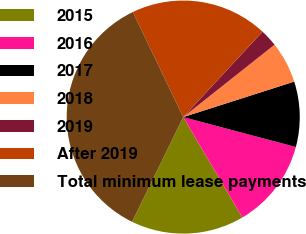<chart> <loc_0><loc_0><loc_500><loc_500><pie_chart><fcel>2015<fcel>2016<fcel>2017<fcel>2018<fcel>2019<fcel>After 2019<fcel>Total minimum lease payments<nl><fcel>15.71%<fcel>12.39%<fcel>9.06%<fcel>5.74%<fcel>2.42%<fcel>19.03%<fcel>35.65%<nl></chart> 